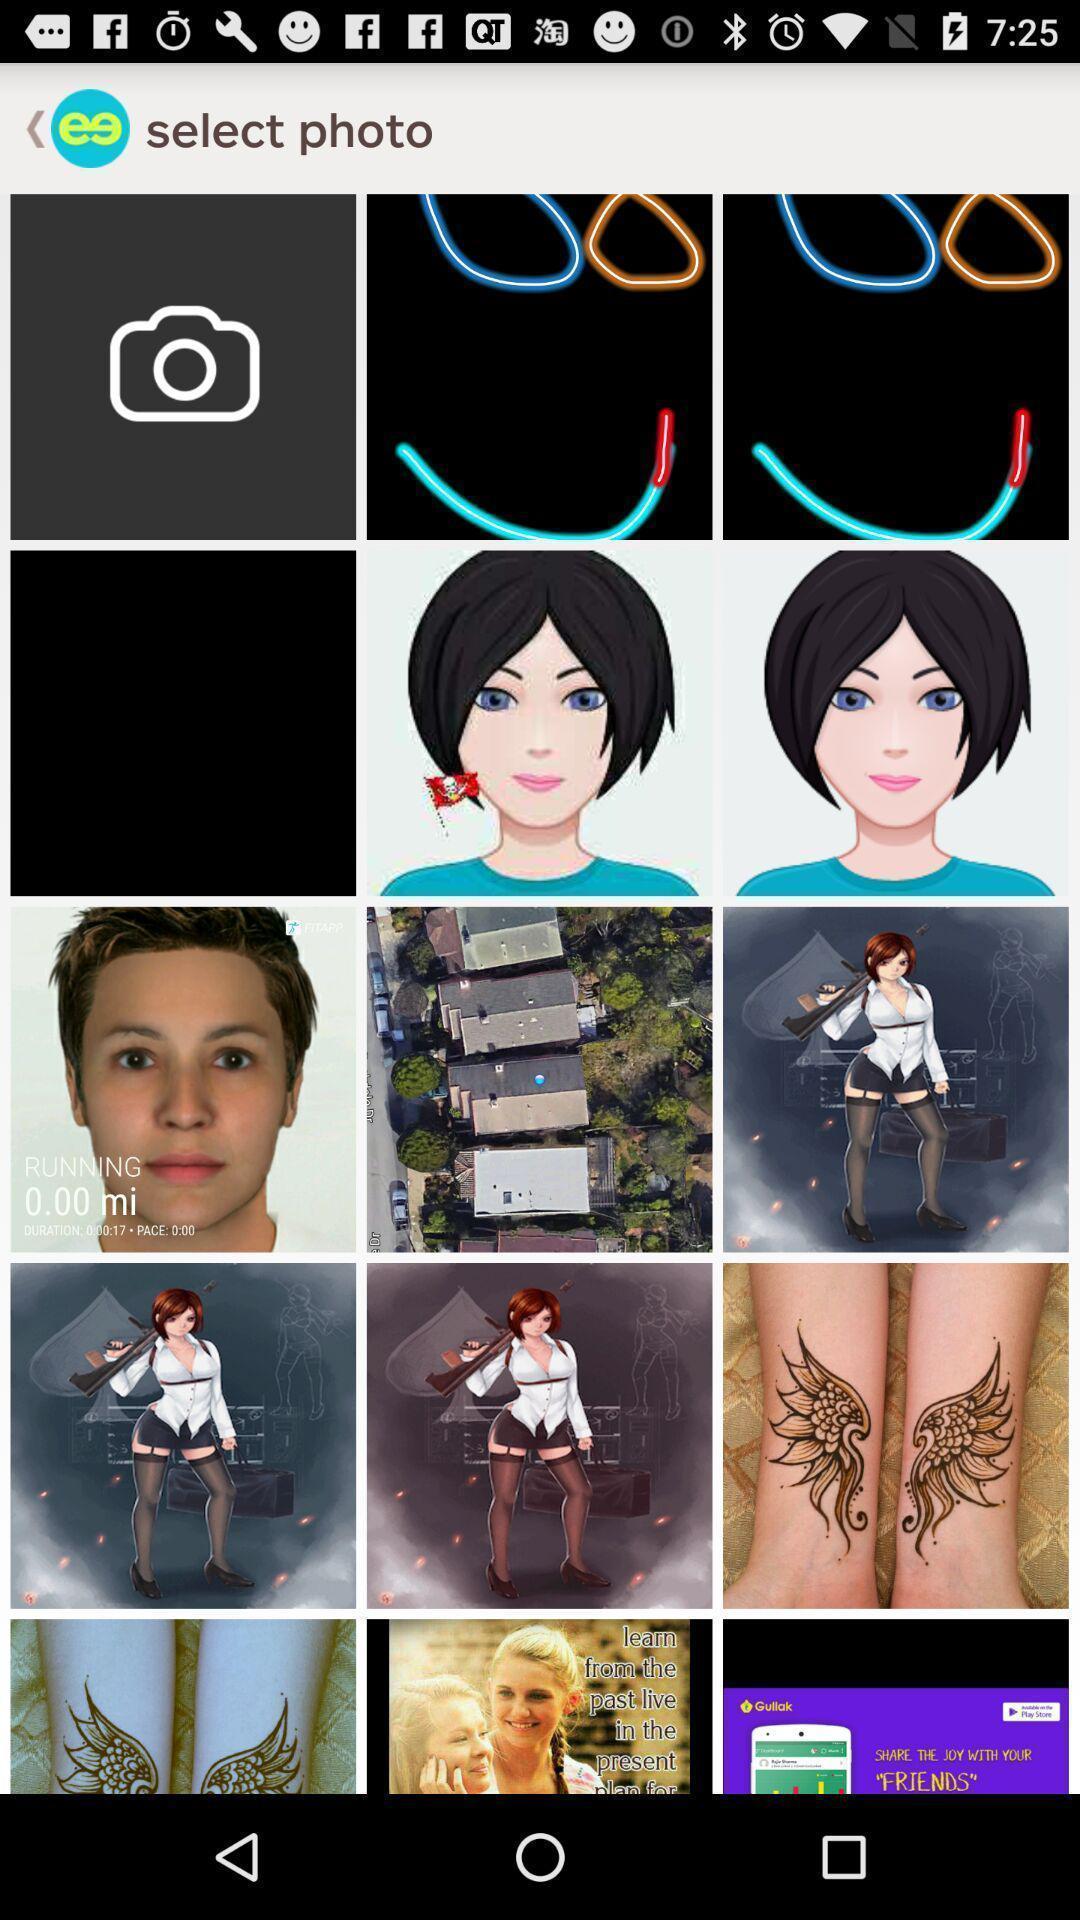Describe the key features of this screenshot. Screen displaying list of images. 